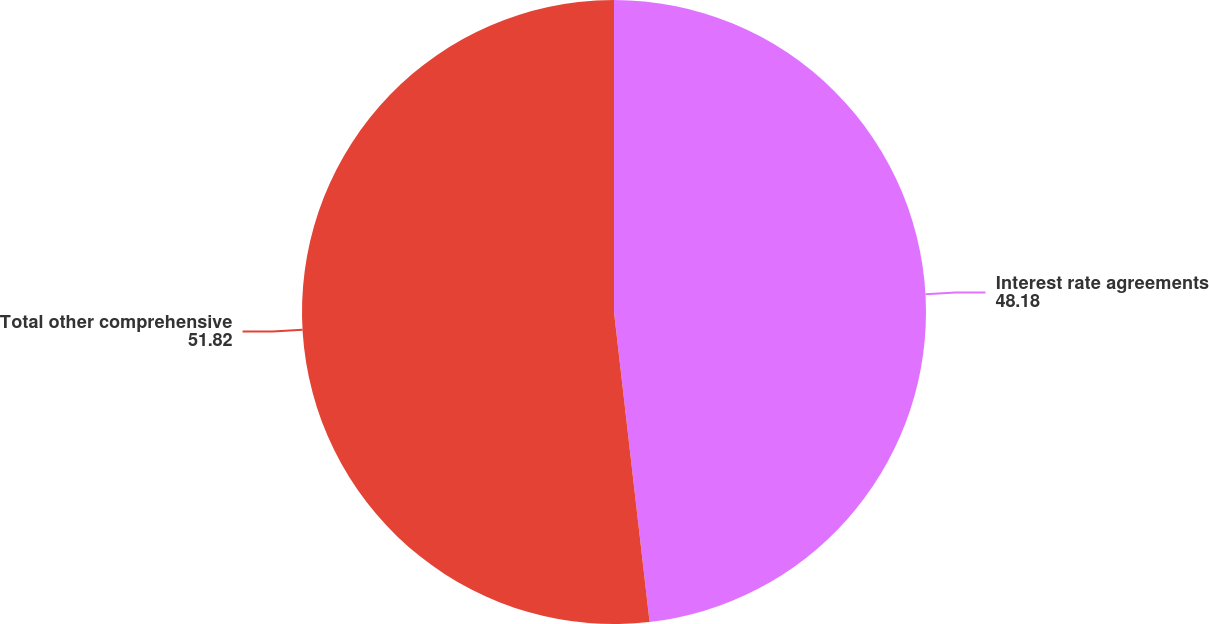<chart> <loc_0><loc_0><loc_500><loc_500><pie_chart><fcel>Interest rate agreements<fcel>Total other comprehensive<nl><fcel>48.18%<fcel>51.82%<nl></chart> 